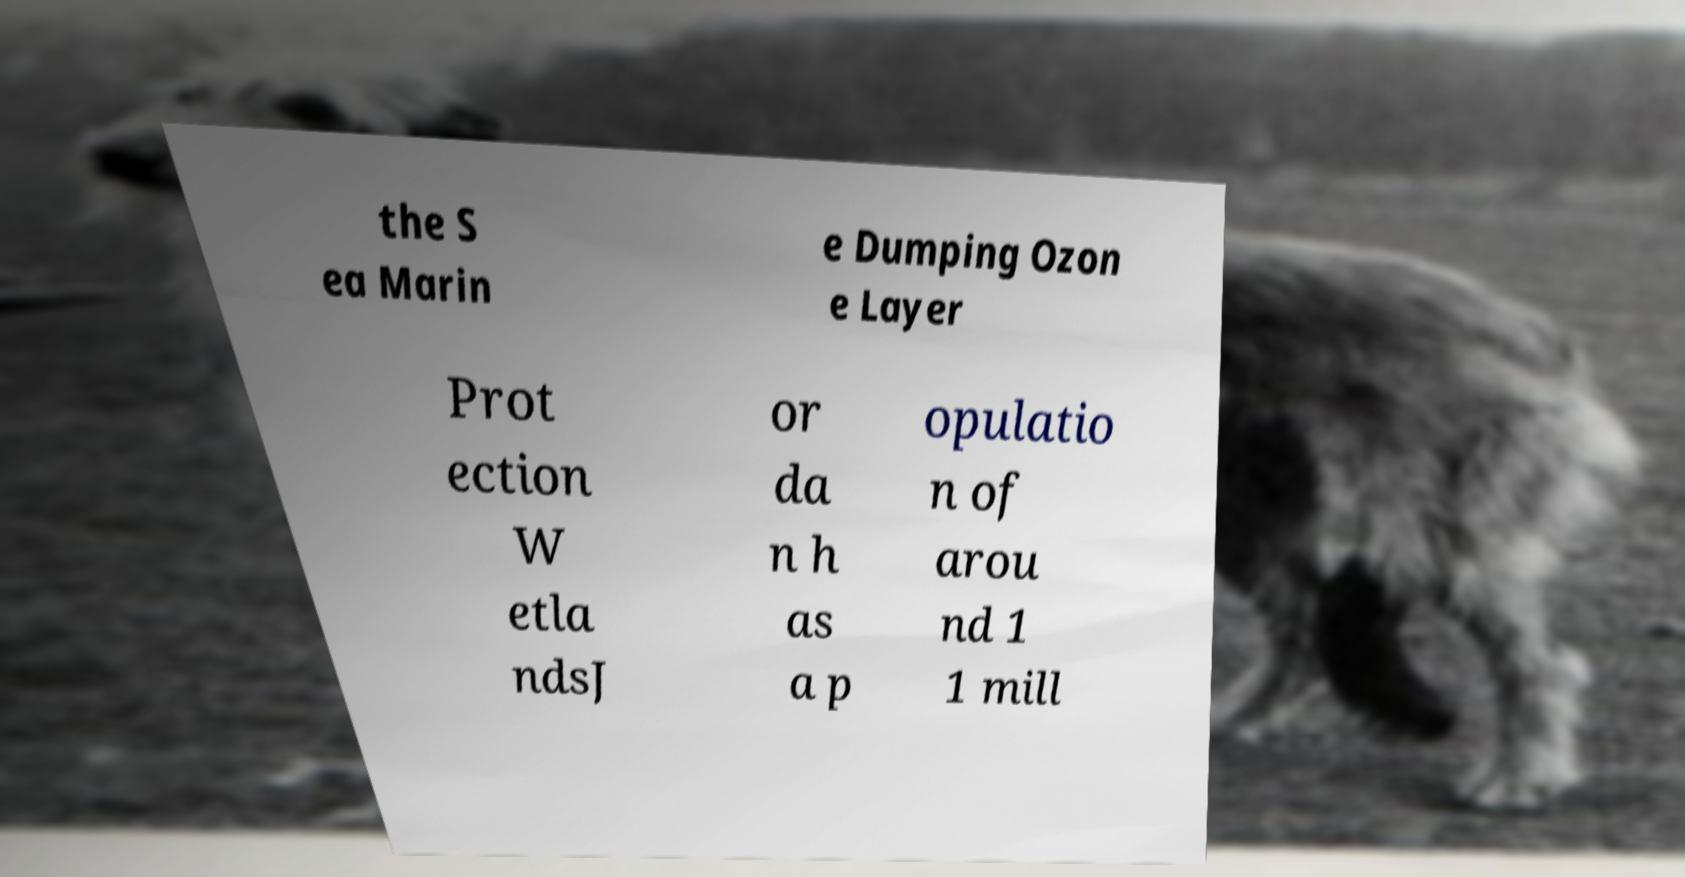What messages or text are displayed in this image? I need them in a readable, typed format. the S ea Marin e Dumping Ozon e Layer Prot ection W etla ndsJ or da n h as a p opulatio n of arou nd 1 1 mill 